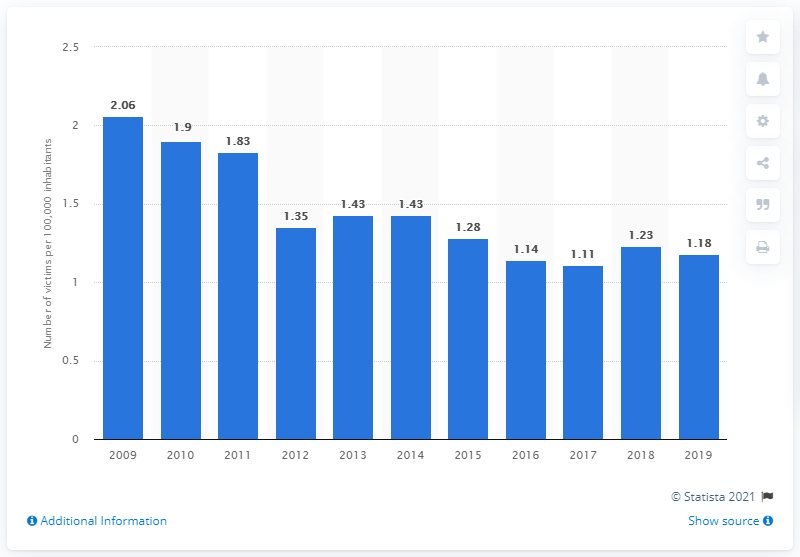Indicate a few pertinent items in this graphic. In 2019, the homicide rate in Finland was 1.18 per 100,000 inhabitants. 